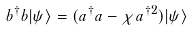Convert formula to latex. <formula><loc_0><loc_0><loc_500><loc_500>b ^ { \dagger } b | \psi \rangle = ( a ^ { \dagger } a - \chi a ^ { \dagger 2 } ) | \psi \rangle</formula> 